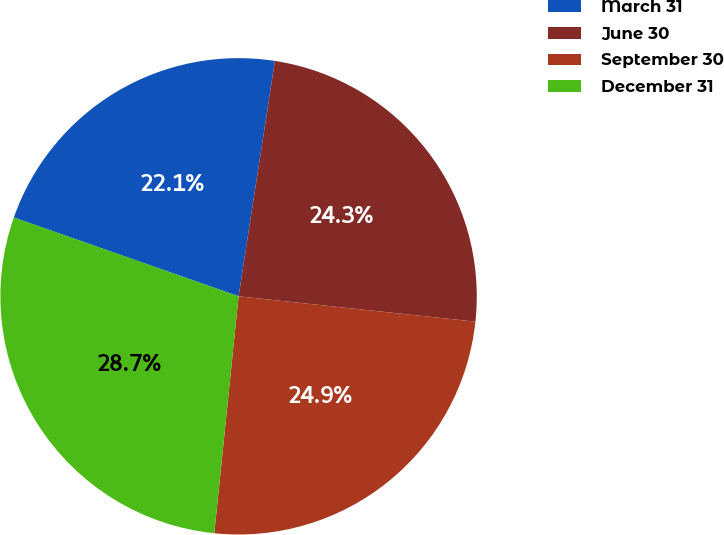Convert chart to OTSL. <chart><loc_0><loc_0><loc_500><loc_500><pie_chart><fcel>March 31<fcel>June 30<fcel>September 30<fcel>December 31<nl><fcel>22.07%<fcel>24.26%<fcel>24.93%<fcel>28.74%<nl></chart> 